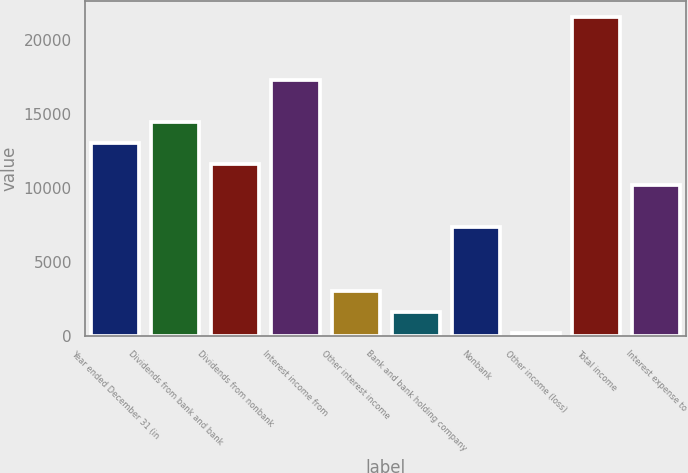Convert chart to OTSL. <chart><loc_0><loc_0><loc_500><loc_500><bar_chart><fcel>Year ended December 31 (in<fcel>Dividends from bank and bank<fcel>Dividends from nonbank<fcel>Interest income from<fcel>Other interest income<fcel>Bank and bank holding company<fcel>Nonbank<fcel>Other income (loss)<fcel>Total income<fcel>Interest expense to<nl><fcel>13020.2<fcel>14444<fcel>11596.4<fcel>17291.6<fcel>3053.6<fcel>1629.8<fcel>7325<fcel>206<fcel>21563<fcel>10172.6<nl></chart> 